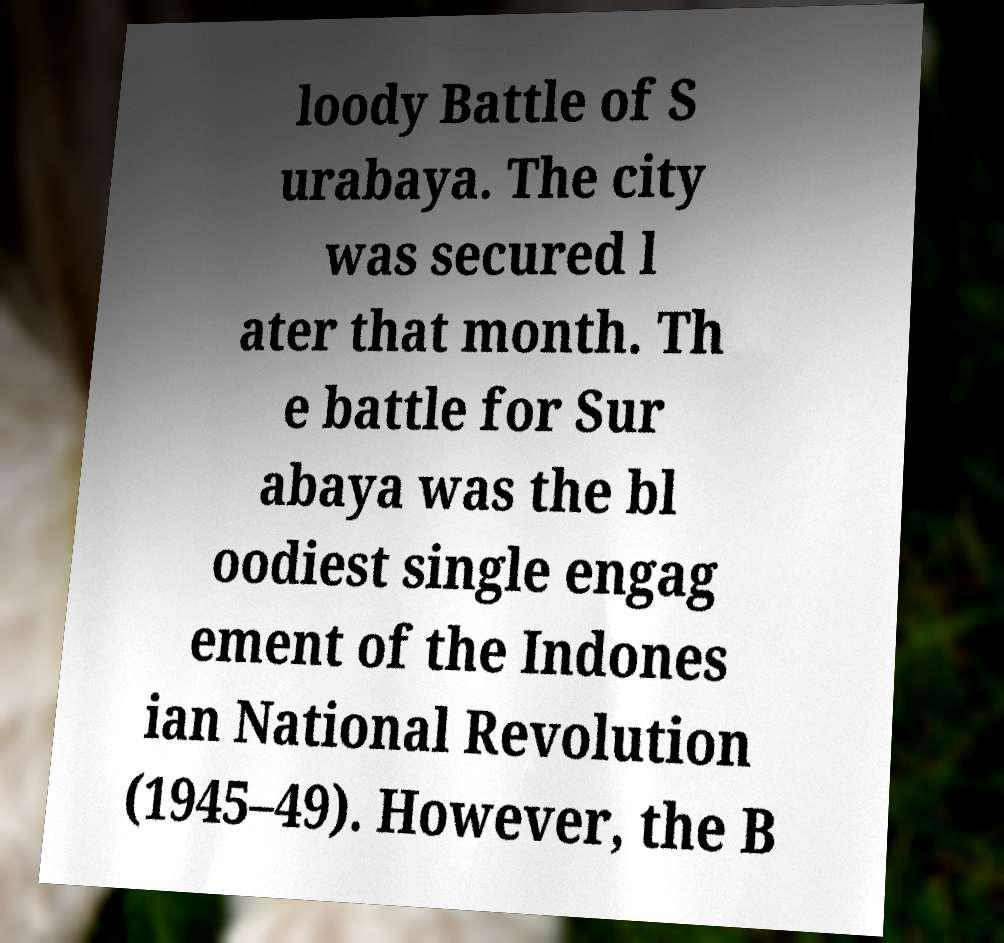Can you accurately transcribe the text from the provided image for me? loody Battle of S urabaya. The city was secured l ater that month. Th e battle for Sur abaya was the bl oodiest single engag ement of the Indones ian National Revolution (1945–49). However, the B 